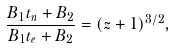Convert formula to latex. <formula><loc_0><loc_0><loc_500><loc_500>\frac { B _ { 1 } t _ { n } + B _ { 2 } } { B _ { 1 } t _ { e } + B _ { 2 } } = ( z + 1 ) ^ { 3 / 2 } ,</formula> 